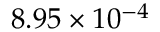<formula> <loc_0><loc_0><loc_500><loc_500>8 . 9 5 \times 1 0 ^ { - 4 }</formula> 